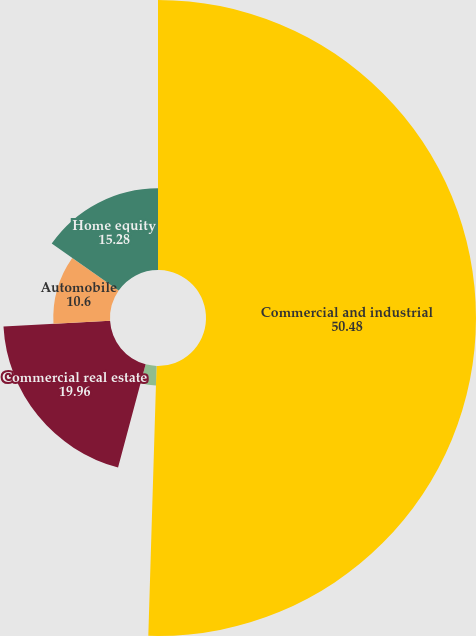<chart> <loc_0><loc_0><loc_500><loc_500><pie_chart><fcel>Commercial and industrial<fcel>Construction<fcel>Commercial real estate<fcel>Automobile<fcel>Home equity<nl><fcel>50.48%<fcel>3.67%<fcel>19.96%<fcel>10.6%<fcel>15.28%<nl></chart> 